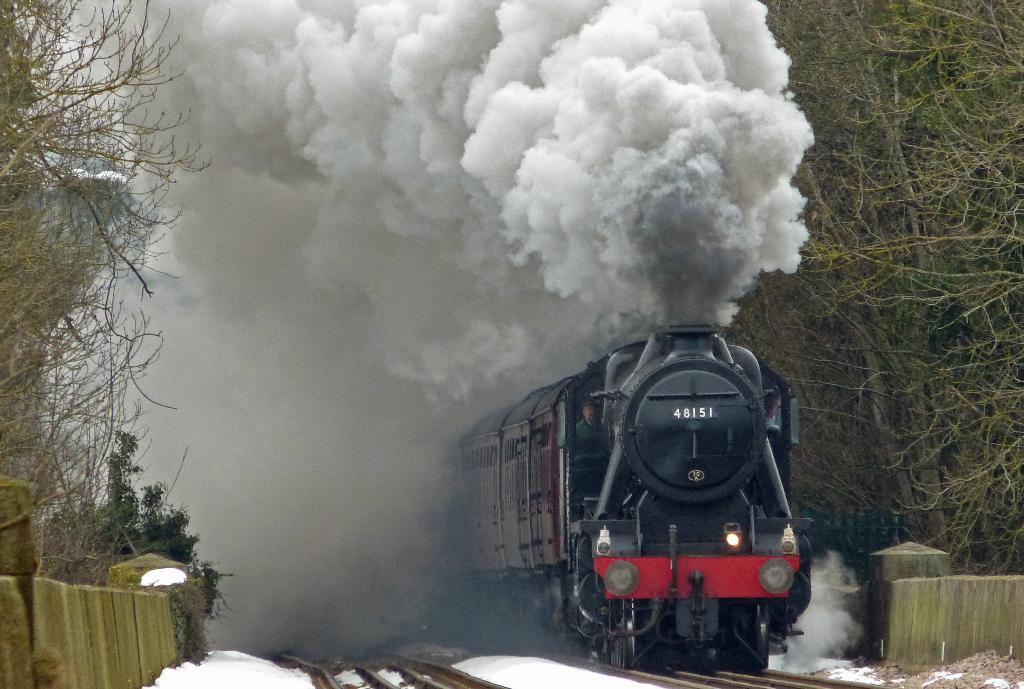Could you give a brief overview of what you see in this image? Here in this picture we can see a train running on the railway track and we can see the smoke released through the and beside that on either side we can see snow covered on the ground and we can also see plants and trees present. 